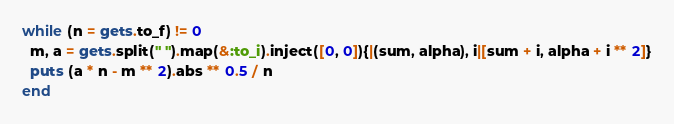Convert code to text. <code><loc_0><loc_0><loc_500><loc_500><_Ruby_>while (n = gets.to_f) != 0
  m, a = gets.split(" ").map(&:to_i).inject([0, 0]){|(sum, alpha), i|[sum + i, alpha + i ** 2]}
  puts (a * n - m ** 2).abs ** 0.5 / n
end</code> 